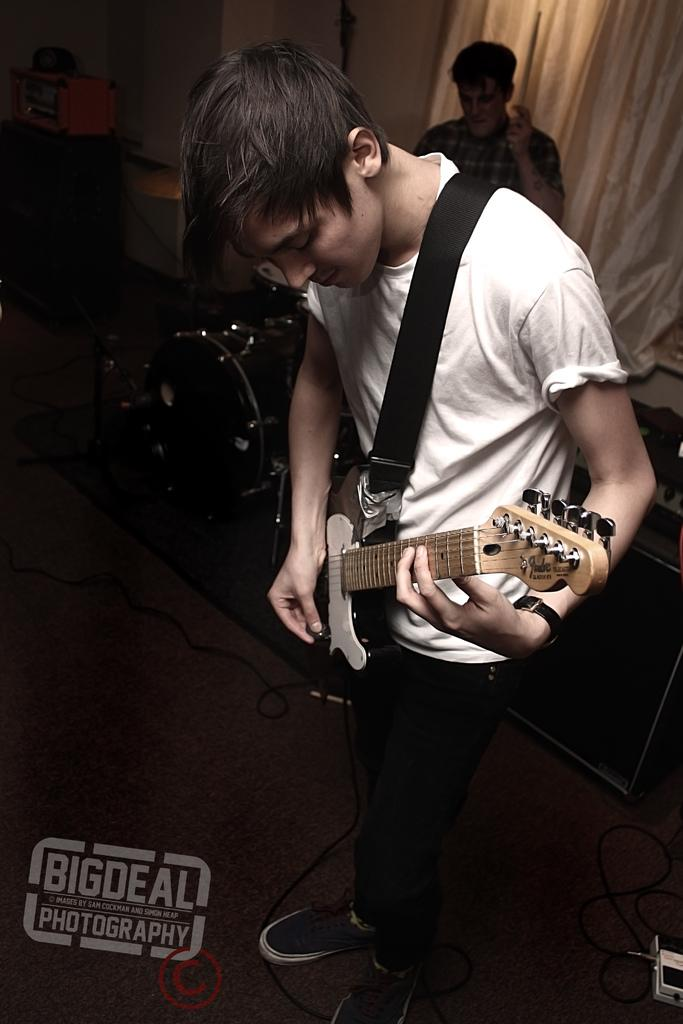What is the main subject of the image? There is a person standing and holding a guitar in the center of the image. What can be seen in the background of the image? There is a wall, a curtain, and another person standing in the background of the image. Are there any musical instruments visible in the image? Yes, there are musical instruments in the background of the image. What is the weight of the debt owed by the stranger in the image? There is no mention of debt or a stranger in the image, so it is impossible to determine the weight of any debt owed. 